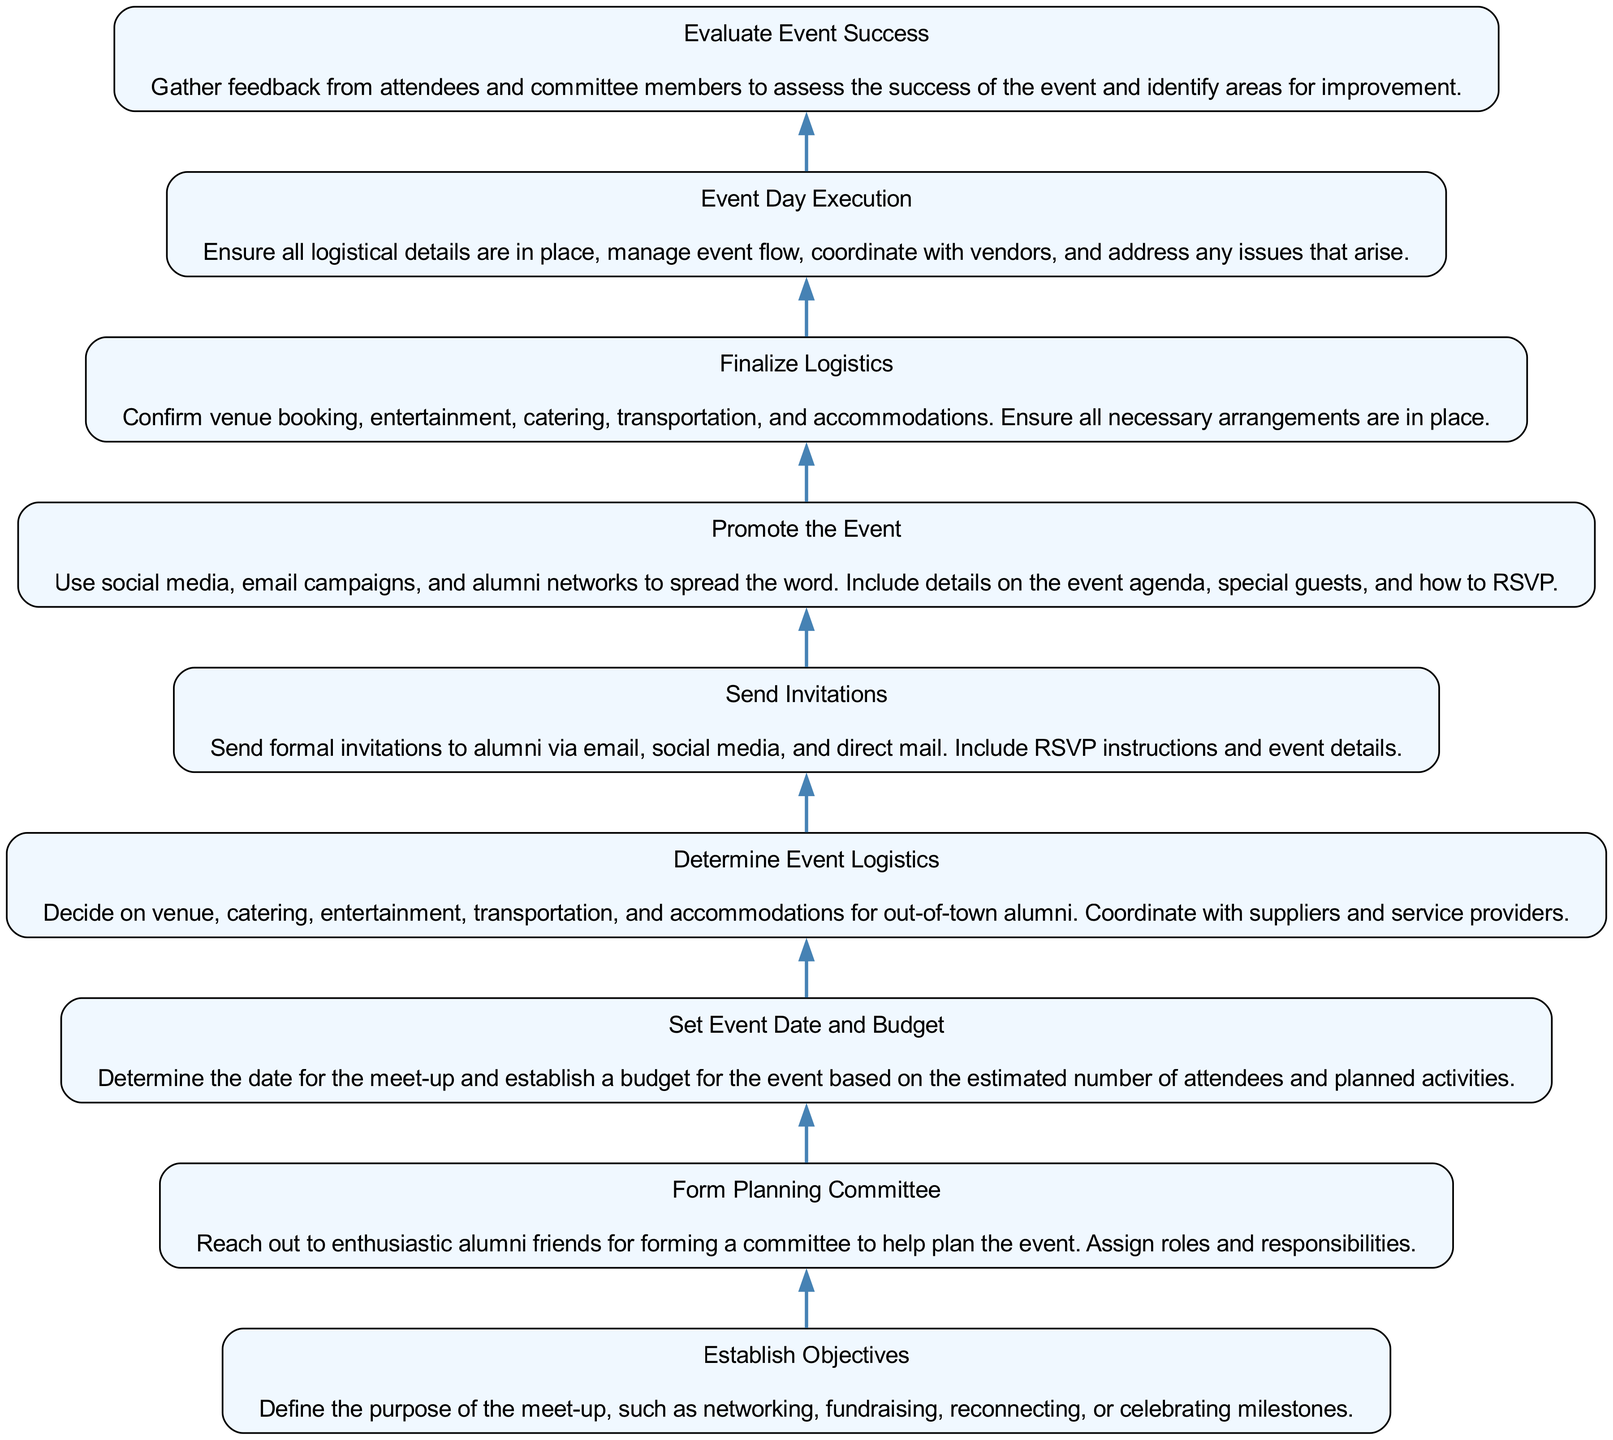What is the first step in planning the alumni meet-up? The first step is "Establish Objectives." It sets the purpose for the event, guiding the rest of the planning process.
Answer: Establish Objectives How many nodes are there in the diagram? By counting each individual step in the flow, there are a total of 9 nodes representing different stages of the alumni meet-up planning.
Answer: 9 What comes immediately after "Send Invitations"? The next step after "Send Invitations" is "Promote the Event," indicating that promotion follows the invitation process.
Answer: Promote the Event Which step follows "Finalize Logistics"? "Event Day Execution" follows "Finalize Logistics," showing that executing the event occurs after finalizing the necessary arrangements.
Answer: Event Day Execution What is the relationship between "Form Planning Committee" and "Set Event Date and Budget"? "Form Planning Committee" precedes "Set Event Date and Budget," indicating that forming the committee is necessary before deciding on the event date and budget.
Answer: precedes Which node descriptor focuses on feedback collection? The node "Evaluate Event Success" emphasizes gathering feedback from attendees to assess event success and improvement areas.
Answer: Evaluate Event Success What step involves confirming arrangements for out-of-town alumni? "Determine Event Logistics" involves coordinating the essential arrangements needed for out-of-town alumni, ensuring their needs are met.
Answer: Determine Event Logistics After establishing objectives, which step is next? The next step after "Establish Objectives" is "Form Planning Committee," indicating that defining the purpose leads to committee formation.
Answer: Form Planning Committee How does "Promote the Event" connect to the overall planning process? "Promote the Event" is crucial as it communicates details to potential attendees after sending invitations, aiming to increase participation.
Answer: connects as a communication step 